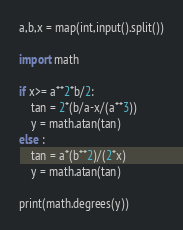Convert code to text. <code><loc_0><loc_0><loc_500><loc_500><_Python_>a,b,x = map(int,input().split())

import math 

if x>= a**2*b/2:
    tan = 2*(b/a-x/(a**3))
    y = math.atan(tan)
else :
    tan = a*(b**2)/(2*x)
    y = math.atan(tan)

print(math.degrees(y))</code> 